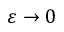<formula> <loc_0><loc_0><loc_500><loc_500>\varepsilon \to 0</formula> 